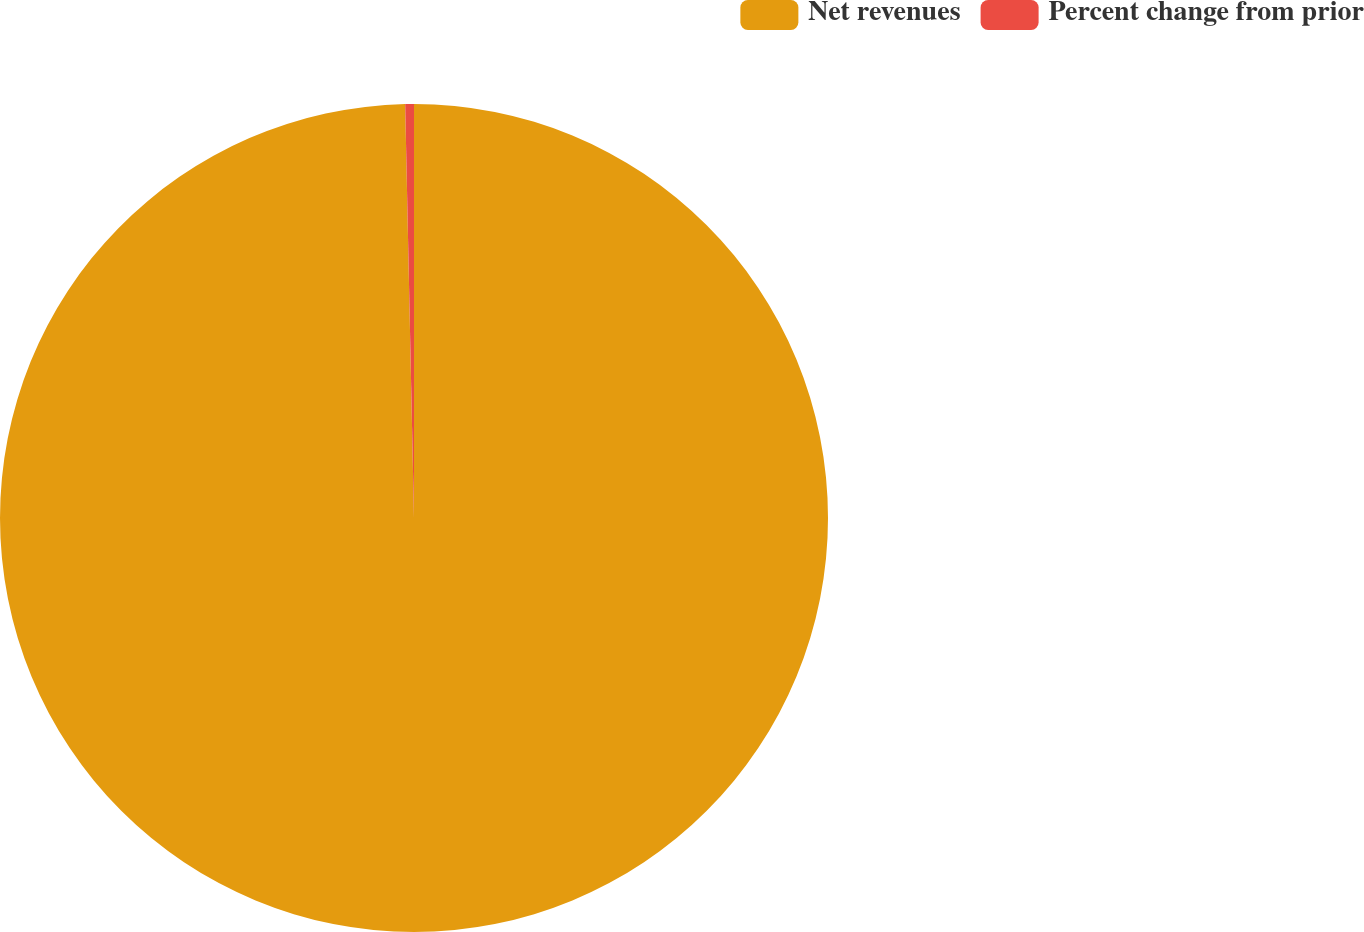Convert chart to OTSL. <chart><loc_0><loc_0><loc_500><loc_500><pie_chart><fcel>Net revenues<fcel>Percent change from prior<nl><fcel>99.66%<fcel>0.34%<nl></chart> 